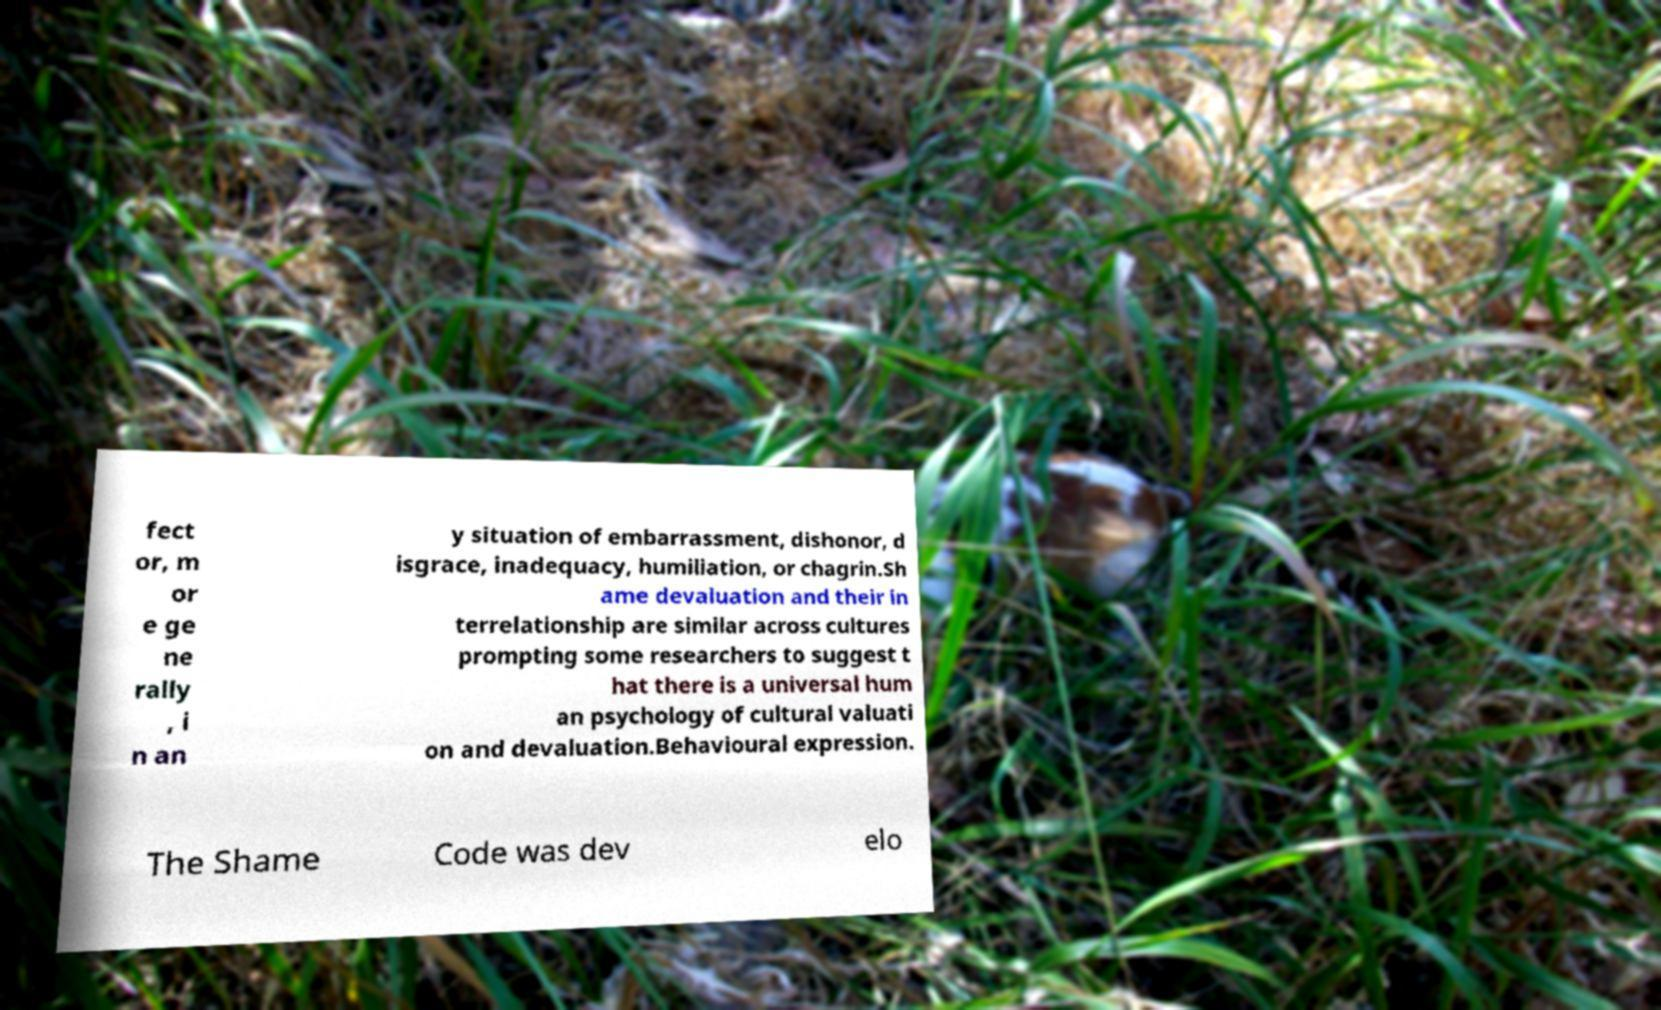I need the written content from this picture converted into text. Can you do that? fect or, m or e ge ne rally , i n an y situation of embarrassment, dishonor, d isgrace, inadequacy, humiliation, or chagrin.Sh ame devaluation and their in terrelationship are similar across cultures prompting some researchers to suggest t hat there is a universal hum an psychology of cultural valuati on and devaluation.Behavioural expression. The Shame Code was dev elo 